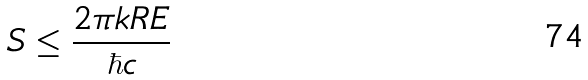<formula> <loc_0><loc_0><loc_500><loc_500>S \leq \frac { 2 \pi k R E } { \hbar { c } }</formula> 